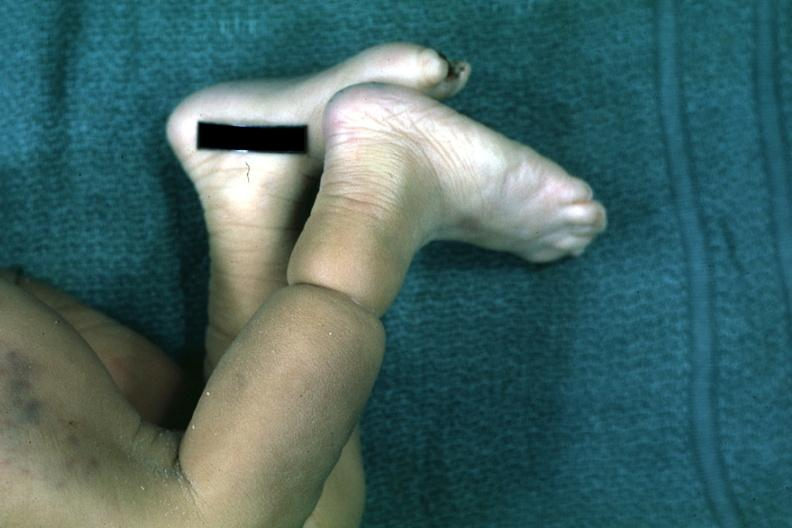what is looks like an amniotic band lesion?
Answer the question using a single word or phrase. That 